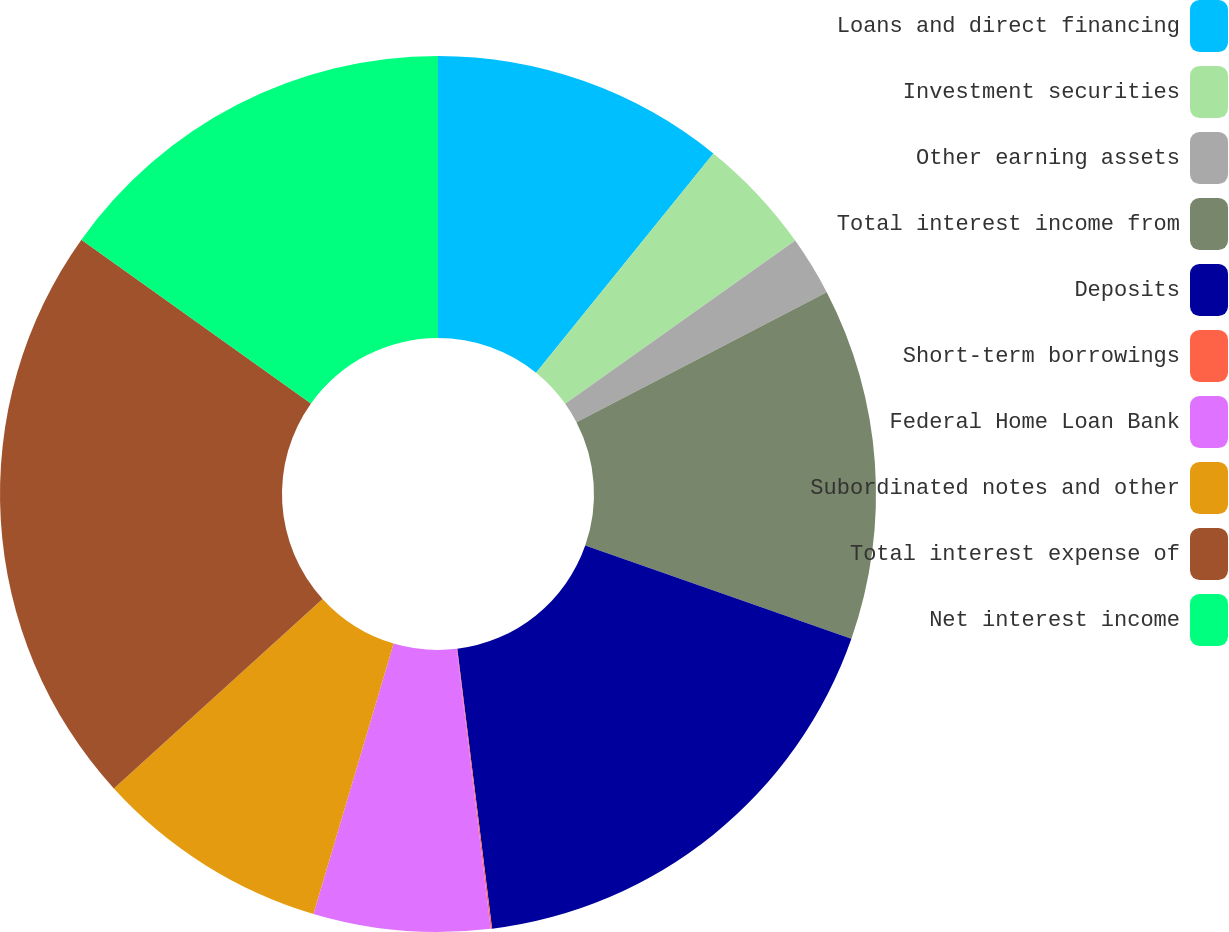<chart> <loc_0><loc_0><loc_500><loc_500><pie_chart><fcel>Loans and direct financing<fcel>Investment securities<fcel>Other earning assets<fcel>Total interest income from<fcel>Deposits<fcel>Short-term borrowings<fcel>Federal Home Loan Bank<fcel>Subordinated notes and other<fcel>Total interest expense of<fcel>Net interest income<nl><fcel>10.82%<fcel>4.36%<fcel>2.2%<fcel>12.98%<fcel>17.67%<fcel>0.05%<fcel>6.51%<fcel>8.67%<fcel>21.6%<fcel>15.14%<nl></chart> 